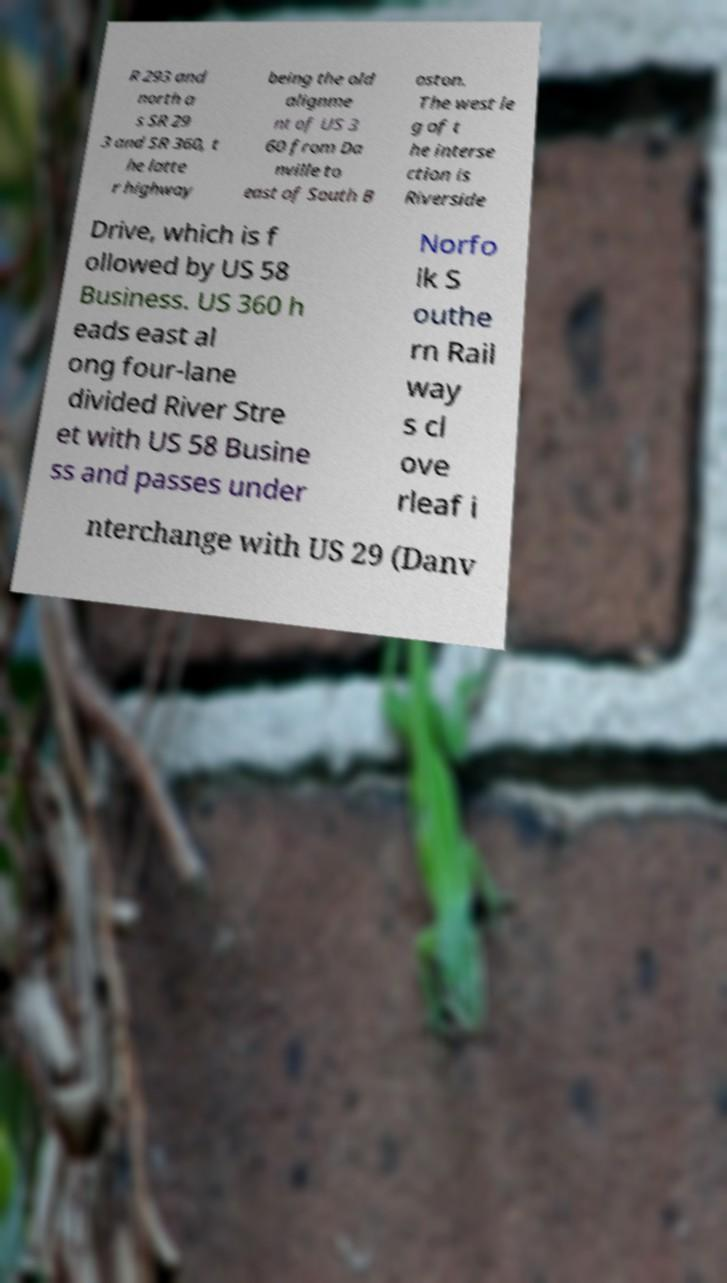For documentation purposes, I need the text within this image transcribed. Could you provide that? R 293 and north a s SR 29 3 and SR 360, t he latte r highway being the old alignme nt of US 3 60 from Da nville to east of South B oston. The west le g of t he interse ction is Riverside Drive, which is f ollowed by US 58 Business. US 360 h eads east al ong four-lane divided River Stre et with US 58 Busine ss and passes under Norfo lk S outhe rn Rail way s cl ove rleaf i nterchange with US 29 (Danv 